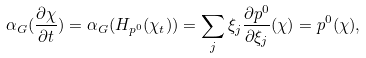Convert formula to latex. <formula><loc_0><loc_0><loc_500><loc_500>\alpha _ { G } ( \frac { \partial \chi } { \partial t } ) = \alpha _ { G } ( H _ { p ^ { 0 } } ( \chi _ { t } ) ) = \sum _ { j } \xi _ { j } \frac { \partial p ^ { 0 } } { \partial \xi _ { j } } ( \chi ) = p ^ { 0 } ( \chi ) ,</formula> 